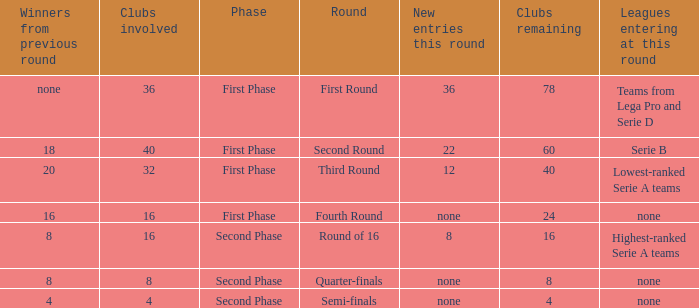Parse the full table. {'header': ['Winners from previous round', 'Clubs involved', 'Phase', 'Round', 'New entries this round', 'Clubs remaining', 'Leagues entering at this round'], 'rows': [['none', '36', 'First Phase', 'First Round', '36', '78', 'Teams from Lega Pro and Serie D'], ['18', '40', 'First Phase', 'Second Round', '22', '60', 'Serie B'], ['20', '32', 'First Phase', 'Third Round', '12', '40', 'Lowest-ranked Serie A teams'], ['16', '16', 'First Phase', 'Fourth Round', 'none', '24', 'none'], ['8', '16', 'Second Phase', 'Round of 16', '8', '16', 'Highest-ranked Serie A teams'], ['8', '8', 'Second Phase', 'Quarter-finals', 'none', '8', 'none'], ['4', '4', 'Second Phase', 'Semi-finals', 'none', '4', 'none']]} Clubs involved is 8, what number would you find from winners from previous round? 8.0. 